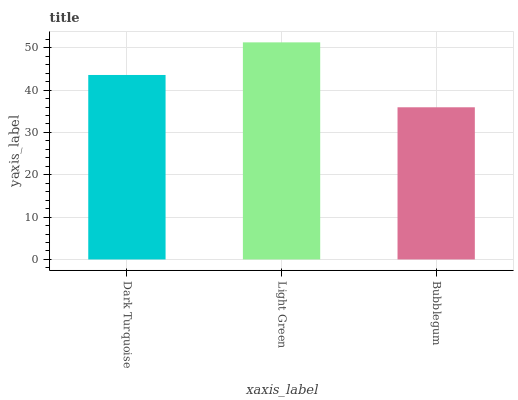Is Light Green the minimum?
Answer yes or no. No. Is Bubblegum the maximum?
Answer yes or no. No. Is Light Green greater than Bubblegum?
Answer yes or no. Yes. Is Bubblegum less than Light Green?
Answer yes or no. Yes. Is Bubblegum greater than Light Green?
Answer yes or no. No. Is Light Green less than Bubblegum?
Answer yes or no. No. Is Dark Turquoise the high median?
Answer yes or no. Yes. Is Dark Turquoise the low median?
Answer yes or no. Yes. Is Light Green the high median?
Answer yes or no. No. Is Light Green the low median?
Answer yes or no. No. 